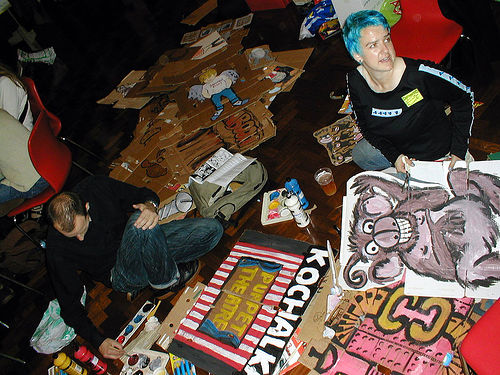<image>
Is there a man on the sign? No. The man is not positioned on the sign. They may be near each other, but the man is not supported by or resting on top of the sign. Where is the drinking glass in relation to the floor? Is it to the left of the floor? No. The drinking glass is not to the left of the floor. From this viewpoint, they have a different horizontal relationship. 